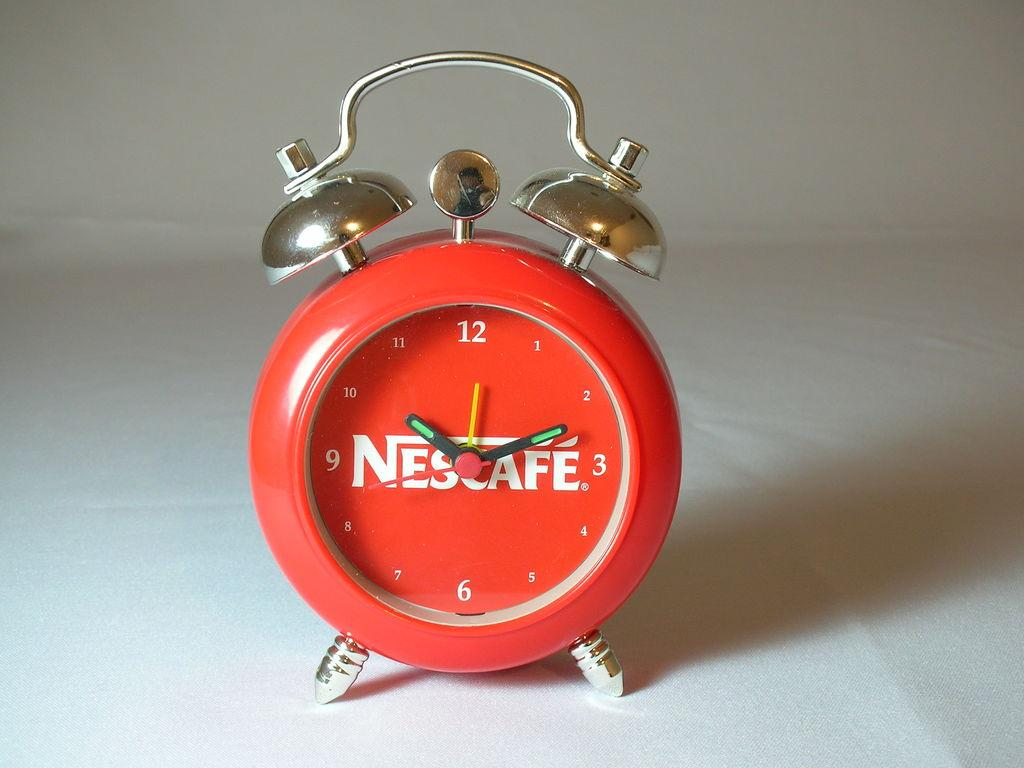Provide a one-sentence caption for the provided image. A red old fashioned alarm clock has the word Nescafe printed in the center of its face. 